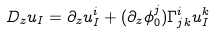<formula> <loc_0><loc_0><loc_500><loc_500>D _ { z } u _ { I } = \partial _ { z } u _ { I } ^ { i } + ( \partial _ { z } \phi _ { 0 } ^ { j } ) \Gamma _ { j k } ^ { i } u _ { I } ^ { k }</formula> 